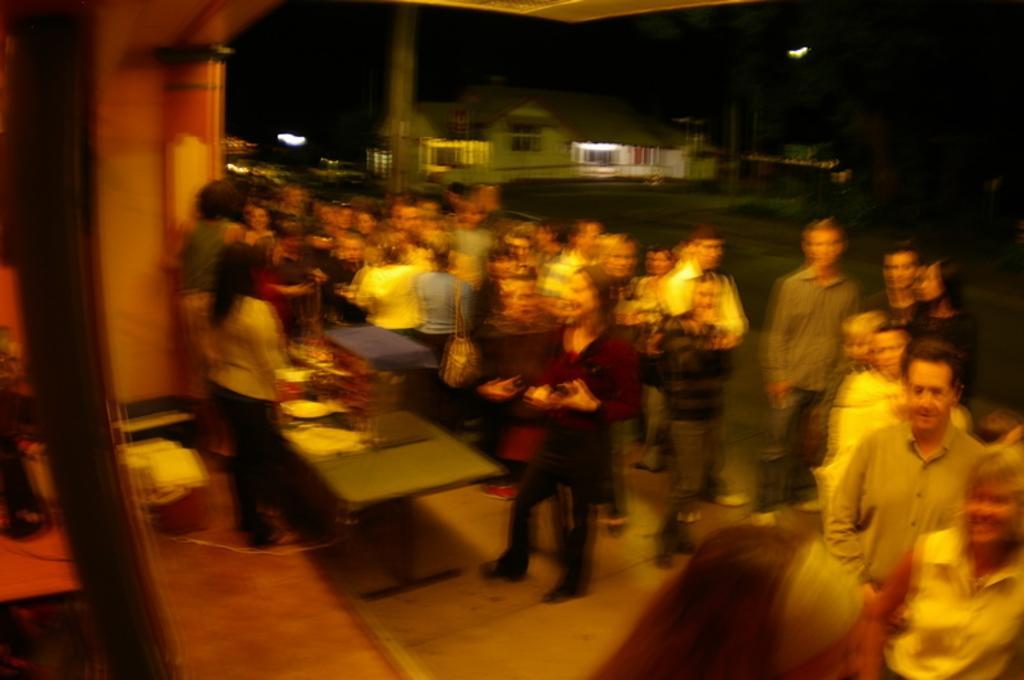Can you describe this image briefly? In this picture there are few persons standing and there are two persons standing in front of a table which has few objects on it and there is a house and trees in the background. 